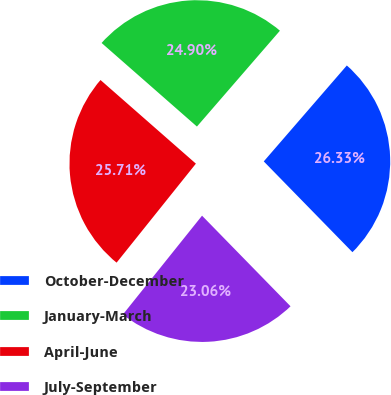<chart> <loc_0><loc_0><loc_500><loc_500><pie_chart><fcel>October-December<fcel>January-March<fcel>April-June<fcel>July-September<nl><fcel>26.33%<fcel>24.9%<fcel>25.71%<fcel>23.06%<nl></chart> 